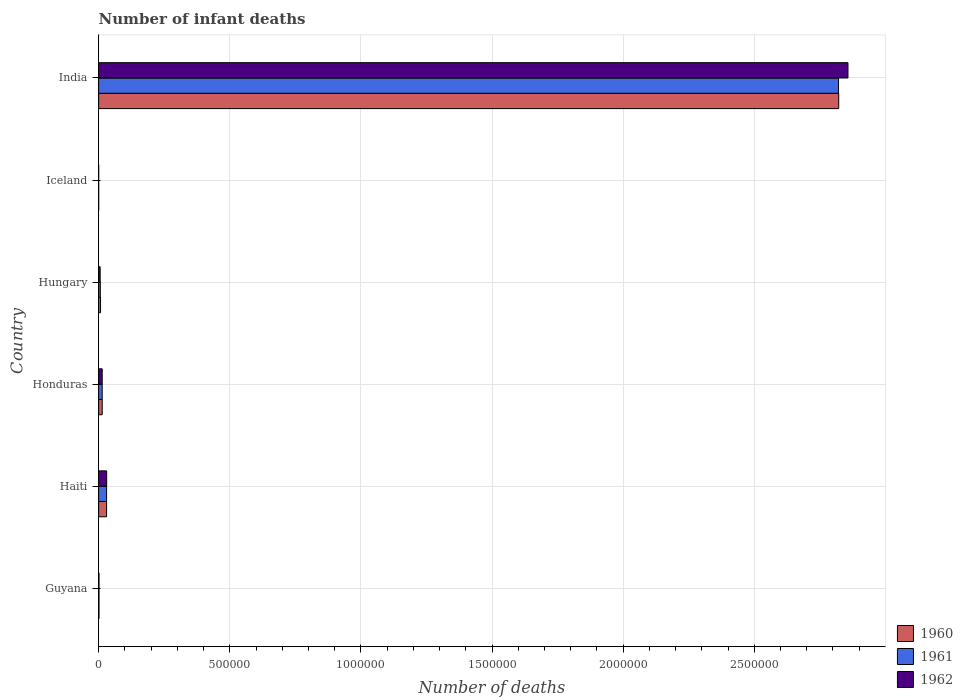How many different coloured bars are there?
Your answer should be very brief. 3. Are the number of bars on each tick of the Y-axis equal?
Offer a very short reply. Yes. What is the label of the 4th group of bars from the top?
Keep it short and to the point. Honduras. What is the number of infant deaths in 1962 in Hungary?
Ensure brevity in your answer.  5804. Across all countries, what is the maximum number of infant deaths in 1961?
Provide a short and direct response. 2.82e+06. Across all countries, what is the minimum number of infant deaths in 1961?
Give a very brief answer. 85. In which country was the number of infant deaths in 1960 maximum?
Your answer should be compact. India. What is the total number of infant deaths in 1961 in the graph?
Keep it short and to the point. 2.87e+06. What is the difference between the number of infant deaths in 1962 in Iceland and that in India?
Give a very brief answer. -2.86e+06. What is the difference between the number of infant deaths in 1961 in India and the number of infant deaths in 1962 in Hungary?
Make the answer very short. 2.82e+06. What is the average number of infant deaths in 1960 per country?
Your answer should be compact. 4.79e+05. What is the ratio of the number of infant deaths in 1960 in Guyana to that in Iceland?
Your answer should be compact. 15.6. Is the number of infant deaths in 1962 in Guyana less than that in Haiti?
Your answer should be very brief. Yes. Is the difference between the number of infant deaths in 1960 in Honduras and India greater than the difference between the number of infant deaths in 1961 in Honduras and India?
Your response must be concise. No. What is the difference between the highest and the second highest number of infant deaths in 1962?
Offer a very short reply. 2.83e+06. What is the difference between the highest and the lowest number of infant deaths in 1961?
Offer a very short reply. 2.82e+06. Is the sum of the number of infant deaths in 1960 in Haiti and Honduras greater than the maximum number of infant deaths in 1961 across all countries?
Make the answer very short. No. What does the 1st bar from the top in Hungary represents?
Provide a short and direct response. 1962. What does the 3rd bar from the bottom in Iceland represents?
Provide a succinct answer. 1962. Is it the case that in every country, the sum of the number of infant deaths in 1962 and number of infant deaths in 1960 is greater than the number of infant deaths in 1961?
Offer a very short reply. Yes. How many bars are there?
Make the answer very short. 18. How many countries are there in the graph?
Give a very brief answer. 6. Are the values on the major ticks of X-axis written in scientific E-notation?
Provide a succinct answer. No. Does the graph contain grids?
Your answer should be very brief. Yes. How many legend labels are there?
Make the answer very short. 3. How are the legend labels stacked?
Offer a very short reply. Vertical. What is the title of the graph?
Make the answer very short. Number of infant deaths. Does "1960" appear as one of the legend labels in the graph?
Give a very brief answer. Yes. What is the label or title of the X-axis?
Keep it short and to the point. Number of deaths. What is the Number of deaths of 1960 in Guyana?
Provide a short and direct response. 1357. What is the Number of deaths of 1961 in Guyana?
Ensure brevity in your answer.  1386. What is the Number of deaths of 1962 in Guyana?
Give a very brief answer. 1434. What is the Number of deaths of 1960 in Haiti?
Ensure brevity in your answer.  3.03e+04. What is the Number of deaths of 1961 in Haiti?
Your answer should be compact. 3.03e+04. What is the Number of deaths in 1962 in Haiti?
Ensure brevity in your answer.  3.07e+04. What is the Number of deaths of 1960 in Honduras?
Your response must be concise. 1.37e+04. What is the Number of deaths in 1961 in Honduras?
Offer a terse response. 1.36e+04. What is the Number of deaths of 1962 in Honduras?
Provide a short and direct response. 1.36e+04. What is the Number of deaths in 1960 in Hungary?
Provide a short and direct response. 7310. What is the Number of deaths in 1961 in Hungary?
Offer a very short reply. 6403. What is the Number of deaths in 1962 in Hungary?
Provide a succinct answer. 5804. What is the Number of deaths in 1960 in India?
Your response must be concise. 2.82e+06. What is the Number of deaths of 1961 in India?
Provide a short and direct response. 2.82e+06. What is the Number of deaths of 1962 in India?
Keep it short and to the point. 2.86e+06. Across all countries, what is the maximum Number of deaths of 1960?
Make the answer very short. 2.82e+06. Across all countries, what is the maximum Number of deaths in 1961?
Keep it short and to the point. 2.82e+06. Across all countries, what is the maximum Number of deaths in 1962?
Offer a very short reply. 2.86e+06. What is the total Number of deaths of 1960 in the graph?
Give a very brief answer. 2.87e+06. What is the total Number of deaths in 1961 in the graph?
Offer a terse response. 2.87e+06. What is the total Number of deaths in 1962 in the graph?
Your answer should be compact. 2.91e+06. What is the difference between the Number of deaths of 1960 in Guyana and that in Haiti?
Provide a succinct answer. -2.89e+04. What is the difference between the Number of deaths of 1961 in Guyana and that in Haiti?
Provide a succinct answer. -2.89e+04. What is the difference between the Number of deaths in 1962 in Guyana and that in Haiti?
Your answer should be compact. -2.92e+04. What is the difference between the Number of deaths in 1960 in Guyana and that in Honduras?
Provide a succinct answer. -1.23e+04. What is the difference between the Number of deaths in 1961 in Guyana and that in Honduras?
Provide a short and direct response. -1.22e+04. What is the difference between the Number of deaths of 1962 in Guyana and that in Honduras?
Provide a short and direct response. -1.21e+04. What is the difference between the Number of deaths of 1960 in Guyana and that in Hungary?
Your response must be concise. -5953. What is the difference between the Number of deaths of 1961 in Guyana and that in Hungary?
Your response must be concise. -5017. What is the difference between the Number of deaths in 1962 in Guyana and that in Hungary?
Provide a short and direct response. -4370. What is the difference between the Number of deaths in 1960 in Guyana and that in Iceland?
Your response must be concise. 1270. What is the difference between the Number of deaths in 1961 in Guyana and that in Iceland?
Offer a very short reply. 1301. What is the difference between the Number of deaths in 1962 in Guyana and that in Iceland?
Ensure brevity in your answer.  1351. What is the difference between the Number of deaths in 1960 in Guyana and that in India?
Give a very brief answer. -2.82e+06. What is the difference between the Number of deaths in 1961 in Guyana and that in India?
Ensure brevity in your answer.  -2.82e+06. What is the difference between the Number of deaths in 1962 in Guyana and that in India?
Give a very brief answer. -2.86e+06. What is the difference between the Number of deaths in 1960 in Haiti and that in Honduras?
Offer a very short reply. 1.66e+04. What is the difference between the Number of deaths in 1961 in Haiti and that in Honduras?
Your response must be concise. 1.67e+04. What is the difference between the Number of deaths of 1962 in Haiti and that in Honduras?
Provide a short and direct response. 1.71e+04. What is the difference between the Number of deaths of 1960 in Haiti and that in Hungary?
Make the answer very short. 2.30e+04. What is the difference between the Number of deaths of 1961 in Haiti and that in Hungary?
Offer a very short reply. 2.39e+04. What is the difference between the Number of deaths in 1962 in Haiti and that in Hungary?
Your answer should be compact. 2.48e+04. What is the difference between the Number of deaths of 1960 in Haiti and that in Iceland?
Offer a terse response. 3.02e+04. What is the difference between the Number of deaths in 1961 in Haiti and that in Iceland?
Keep it short and to the point. 3.02e+04. What is the difference between the Number of deaths of 1962 in Haiti and that in Iceland?
Offer a terse response. 3.06e+04. What is the difference between the Number of deaths in 1960 in Haiti and that in India?
Ensure brevity in your answer.  -2.79e+06. What is the difference between the Number of deaths of 1961 in Haiti and that in India?
Provide a short and direct response. -2.79e+06. What is the difference between the Number of deaths of 1962 in Haiti and that in India?
Offer a very short reply. -2.83e+06. What is the difference between the Number of deaths of 1960 in Honduras and that in Hungary?
Your answer should be very brief. 6364. What is the difference between the Number of deaths in 1961 in Honduras and that in Hungary?
Your answer should be very brief. 7183. What is the difference between the Number of deaths in 1962 in Honduras and that in Hungary?
Your answer should be very brief. 7777. What is the difference between the Number of deaths of 1960 in Honduras and that in Iceland?
Your answer should be compact. 1.36e+04. What is the difference between the Number of deaths of 1961 in Honduras and that in Iceland?
Offer a terse response. 1.35e+04. What is the difference between the Number of deaths in 1962 in Honduras and that in Iceland?
Provide a succinct answer. 1.35e+04. What is the difference between the Number of deaths of 1960 in Honduras and that in India?
Offer a very short reply. -2.81e+06. What is the difference between the Number of deaths of 1961 in Honduras and that in India?
Offer a very short reply. -2.81e+06. What is the difference between the Number of deaths of 1962 in Honduras and that in India?
Keep it short and to the point. -2.84e+06. What is the difference between the Number of deaths of 1960 in Hungary and that in Iceland?
Offer a terse response. 7223. What is the difference between the Number of deaths of 1961 in Hungary and that in Iceland?
Keep it short and to the point. 6318. What is the difference between the Number of deaths in 1962 in Hungary and that in Iceland?
Provide a short and direct response. 5721. What is the difference between the Number of deaths of 1960 in Hungary and that in India?
Offer a very short reply. -2.81e+06. What is the difference between the Number of deaths in 1961 in Hungary and that in India?
Keep it short and to the point. -2.81e+06. What is the difference between the Number of deaths of 1962 in Hungary and that in India?
Provide a succinct answer. -2.85e+06. What is the difference between the Number of deaths in 1960 in Iceland and that in India?
Make the answer very short. -2.82e+06. What is the difference between the Number of deaths in 1961 in Iceland and that in India?
Offer a terse response. -2.82e+06. What is the difference between the Number of deaths of 1962 in Iceland and that in India?
Offer a very short reply. -2.86e+06. What is the difference between the Number of deaths in 1960 in Guyana and the Number of deaths in 1961 in Haiti?
Provide a succinct answer. -2.89e+04. What is the difference between the Number of deaths in 1960 in Guyana and the Number of deaths in 1962 in Haiti?
Ensure brevity in your answer.  -2.93e+04. What is the difference between the Number of deaths in 1961 in Guyana and the Number of deaths in 1962 in Haiti?
Your response must be concise. -2.93e+04. What is the difference between the Number of deaths in 1960 in Guyana and the Number of deaths in 1961 in Honduras?
Offer a terse response. -1.22e+04. What is the difference between the Number of deaths of 1960 in Guyana and the Number of deaths of 1962 in Honduras?
Your response must be concise. -1.22e+04. What is the difference between the Number of deaths of 1961 in Guyana and the Number of deaths of 1962 in Honduras?
Make the answer very short. -1.22e+04. What is the difference between the Number of deaths of 1960 in Guyana and the Number of deaths of 1961 in Hungary?
Your answer should be compact. -5046. What is the difference between the Number of deaths in 1960 in Guyana and the Number of deaths in 1962 in Hungary?
Your answer should be very brief. -4447. What is the difference between the Number of deaths in 1961 in Guyana and the Number of deaths in 1962 in Hungary?
Ensure brevity in your answer.  -4418. What is the difference between the Number of deaths of 1960 in Guyana and the Number of deaths of 1961 in Iceland?
Make the answer very short. 1272. What is the difference between the Number of deaths of 1960 in Guyana and the Number of deaths of 1962 in Iceland?
Offer a terse response. 1274. What is the difference between the Number of deaths of 1961 in Guyana and the Number of deaths of 1962 in Iceland?
Keep it short and to the point. 1303. What is the difference between the Number of deaths of 1960 in Guyana and the Number of deaths of 1961 in India?
Ensure brevity in your answer.  -2.82e+06. What is the difference between the Number of deaths of 1960 in Guyana and the Number of deaths of 1962 in India?
Offer a very short reply. -2.86e+06. What is the difference between the Number of deaths of 1961 in Guyana and the Number of deaths of 1962 in India?
Offer a terse response. -2.86e+06. What is the difference between the Number of deaths in 1960 in Haiti and the Number of deaths in 1961 in Honduras?
Keep it short and to the point. 1.67e+04. What is the difference between the Number of deaths in 1960 in Haiti and the Number of deaths in 1962 in Honduras?
Ensure brevity in your answer.  1.67e+04. What is the difference between the Number of deaths of 1961 in Haiti and the Number of deaths of 1962 in Honduras?
Offer a very short reply. 1.67e+04. What is the difference between the Number of deaths of 1960 in Haiti and the Number of deaths of 1961 in Hungary?
Your answer should be compact. 2.39e+04. What is the difference between the Number of deaths of 1960 in Haiti and the Number of deaths of 1962 in Hungary?
Your response must be concise. 2.45e+04. What is the difference between the Number of deaths in 1961 in Haiti and the Number of deaths in 1962 in Hungary?
Make the answer very short. 2.45e+04. What is the difference between the Number of deaths in 1960 in Haiti and the Number of deaths in 1961 in Iceland?
Ensure brevity in your answer.  3.02e+04. What is the difference between the Number of deaths in 1960 in Haiti and the Number of deaths in 1962 in Iceland?
Your answer should be very brief. 3.02e+04. What is the difference between the Number of deaths of 1961 in Haiti and the Number of deaths of 1962 in Iceland?
Provide a succinct answer. 3.02e+04. What is the difference between the Number of deaths in 1960 in Haiti and the Number of deaths in 1961 in India?
Offer a terse response. -2.79e+06. What is the difference between the Number of deaths in 1960 in Haiti and the Number of deaths in 1962 in India?
Offer a very short reply. -2.83e+06. What is the difference between the Number of deaths of 1961 in Haiti and the Number of deaths of 1962 in India?
Your answer should be compact. -2.83e+06. What is the difference between the Number of deaths in 1960 in Honduras and the Number of deaths in 1961 in Hungary?
Your response must be concise. 7271. What is the difference between the Number of deaths of 1960 in Honduras and the Number of deaths of 1962 in Hungary?
Offer a very short reply. 7870. What is the difference between the Number of deaths in 1961 in Honduras and the Number of deaths in 1962 in Hungary?
Provide a succinct answer. 7782. What is the difference between the Number of deaths of 1960 in Honduras and the Number of deaths of 1961 in Iceland?
Ensure brevity in your answer.  1.36e+04. What is the difference between the Number of deaths of 1960 in Honduras and the Number of deaths of 1962 in Iceland?
Offer a terse response. 1.36e+04. What is the difference between the Number of deaths in 1961 in Honduras and the Number of deaths in 1962 in Iceland?
Provide a succinct answer. 1.35e+04. What is the difference between the Number of deaths of 1960 in Honduras and the Number of deaths of 1961 in India?
Keep it short and to the point. -2.81e+06. What is the difference between the Number of deaths of 1960 in Honduras and the Number of deaths of 1962 in India?
Keep it short and to the point. -2.84e+06. What is the difference between the Number of deaths of 1961 in Honduras and the Number of deaths of 1962 in India?
Offer a terse response. -2.84e+06. What is the difference between the Number of deaths in 1960 in Hungary and the Number of deaths in 1961 in Iceland?
Provide a short and direct response. 7225. What is the difference between the Number of deaths in 1960 in Hungary and the Number of deaths in 1962 in Iceland?
Make the answer very short. 7227. What is the difference between the Number of deaths of 1961 in Hungary and the Number of deaths of 1962 in Iceland?
Your response must be concise. 6320. What is the difference between the Number of deaths in 1960 in Hungary and the Number of deaths in 1961 in India?
Your answer should be compact. -2.81e+06. What is the difference between the Number of deaths in 1960 in Hungary and the Number of deaths in 1962 in India?
Provide a short and direct response. -2.85e+06. What is the difference between the Number of deaths of 1961 in Hungary and the Number of deaths of 1962 in India?
Your response must be concise. -2.85e+06. What is the difference between the Number of deaths in 1960 in Iceland and the Number of deaths in 1961 in India?
Offer a very short reply. -2.82e+06. What is the difference between the Number of deaths in 1960 in Iceland and the Number of deaths in 1962 in India?
Offer a terse response. -2.86e+06. What is the difference between the Number of deaths of 1961 in Iceland and the Number of deaths of 1962 in India?
Your answer should be very brief. -2.86e+06. What is the average Number of deaths in 1960 per country?
Provide a short and direct response. 4.79e+05. What is the average Number of deaths of 1961 per country?
Your answer should be very brief. 4.79e+05. What is the average Number of deaths of 1962 per country?
Your answer should be compact. 4.85e+05. What is the difference between the Number of deaths in 1960 and Number of deaths in 1961 in Guyana?
Keep it short and to the point. -29. What is the difference between the Number of deaths in 1960 and Number of deaths in 1962 in Guyana?
Provide a succinct answer. -77. What is the difference between the Number of deaths in 1961 and Number of deaths in 1962 in Guyana?
Offer a terse response. -48. What is the difference between the Number of deaths of 1960 and Number of deaths of 1962 in Haiti?
Make the answer very short. -373. What is the difference between the Number of deaths of 1961 and Number of deaths of 1962 in Haiti?
Offer a very short reply. -352. What is the difference between the Number of deaths in 1960 and Number of deaths in 1961 in Honduras?
Your response must be concise. 88. What is the difference between the Number of deaths in 1960 and Number of deaths in 1962 in Honduras?
Give a very brief answer. 93. What is the difference between the Number of deaths of 1960 and Number of deaths of 1961 in Hungary?
Your response must be concise. 907. What is the difference between the Number of deaths in 1960 and Number of deaths in 1962 in Hungary?
Your answer should be compact. 1506. What is the difference between the Number of deaths of 1961 and Number of deaths of 1962 in Hungary?
Offer a terse response. 599. What is the difference between the Number of deaths of 1960 and Number of deaths of 1962 in Iceland?
Your answer should be very brief. 4. What is the difference between the Number of deaths of 1960 and Number of deaths of 1961 in India?
Offer a very short reply. 784. What is the difference between the Number of deaths in 1960 and Number of deaths in 1962 in India?
Keep it short and to the point. -3.53e+04. What is the difference between the Number of deaths of 1961 and Number of deaths of 1962 in India?
Ensure brevity in your answer.  -3.60e+04. What is the ratio of the Number of deaths of 1960 in Guyana to that in Haiti?
Ensure brevity in your answer.  0.04. What is the ratio of the Number of deaths of 1961 in Guyana to that in Haiti?
Your answer should be very brief. 0.05. What is the ratio of the Number of deaths of 1962 in Guyana to that in Haiti?
Your response must be concise. 0.05. What is the ratio of the Number of deaths of 1960 in Guyana to that in Honduras?
Keep it short and to the point. 0.1. What is the ratio of the Number of deaths of 1961 in Guyana to that in Honduras?
Your response must be concise. 0.1. What is the ratio of the Number of deaths in 1962 in Guyana to that in Honduras?
Your answer should be very brief. 0.11. What is the ratio of the Number of deaths in 1960 in Guyana to that in Hungary?
Offer a terse response. 0.19. What is the ratio of the Number of deaths in 1961 in Guyana to that in Hungary?
Offer a very short reply. 0.22. What is the ratio of the Number of deaths in 1962 in Guyana to that in Hungary?
Your answer should be very brief. 0.25. What is the ratio of the Number of deaths of 1960 in Guyana to that in Iceland?
Make the answer very short. 15.6. What is the ratio of the Number of deaths of 1961 in Guyana to that in Iceland?
Make the answer very short. 16.31. What is the ratio of the Number of deaths in 1962 in Guyana to that in Iceland?
Provide a succinct answer. 17.28. What is the ratio of the Number of deaths in 1960 in Guyana to that in India?
Make the answer very short. 0. What is the ratio of the Number of deaths of 1962 in Guyana to that in India?
Offer a very short reply. 0. What is the ratio of the Number of deaths of 1960 in Haiti to that in Honduras?
Your response must be concise. 2.21. What is the ratio of the Number of deaths of 1961 in Haiti to that in Honduras?
Provide a short and direct response. 2.23. What is the ratio of the Number of deaths of 1962 in Haiti to that in Honduras?
Your answer should be compact. 2.26. What is the ratio of the Number of deaths of 1960 in Haiti to that in Hungary?
Ensure brevity in your answer.  4.14. What is the ratio of the Number of deaths in 1961 in Haiti to that in Hungary?
Make the answer very short. 4.73. What is the ratio of the Number of deaths of 1962 in Haiti to that in Hungary?
Offer a terse response. 5.28. What is the ratio of the Number of deaths in 1960 in Haiti to that in Iceland?
Keep it short and to the point. 348.06. What is the ratio of the Number of deaths in 1961 in Haiti to that in Iceland?
Your response must be concise. 356.49. What is the ratio of the Number of deaths in 1962 in Haiti to that in Iceland?
Provide a short and direct response. 369.33. What is the ratio of the Number of deaths in 1960 in Haiti to that in India?
Provide a succinct answer. 0.01. What is the ratio of the Number of deaths of 1961 in Haiti to that in India?
Offer a very short reply. 0.01. What is the ratio of the Number of deaths in 1962 in Haiti to that in India?
Provide a short and direct response. 0.01. What is the ratio of the Number of deaths in 1960 in Honduras to that in Hungary?
Keep it short and to the point. 1.87. What is the ratio of the Number of deaths of 1961 in Honduras to that in Hungary?
Your response must be concise. 2.12. What is the ratio of the Number of deaths in 1962 in Honduras to that in Hungary?
Offer a very short reply. 2.34. What is the ratio of the Number of deaths in 1960 in Honduras to that in Iceland?
Your response must be concise. 157.17. What is the ratio of the Number of deaths of 1961 in Honduras to that in Iceland?
Offer a terse response. 159.84. What is the ratio of the Number of deaths in 1962 in Honduras to that in Iceland?
Ensure brevity in your answer.  163.63. What is the ratio of the Number of deaths in 1960 in Honduras to that in India?
Offer a very short reply. 0. What is the ratio of the Number of deaths of 1961 in Honduras to that in India?
Your answer should be compact. 0. What is the ratio of the Number of deaths of 1962 in Honduras to that in India?
Your answer should be very brief. 0. What is the ratio of the Number of deaths of 1960 in Hungary to that in Iceland?
Your answer should be compact. 84.02. What is the ratio of the Number of deaths of 1961 in Hungary to that in Iceland?
Offer a very short reply. 75.33. What is the ratio of the Number of deaths in 1962 in Hungary to that in Iceland?
Keep it short and to the point. 69.93. What is the ratio of the Number of deaths in 1960 in Hungary to that in India?
Give a very brief answer. 0. What is the ratio of the Number of deaths in 1961 in Hungary to that in India?
Keep it short and to the point. 0. What is the ratio of the Number of deaths of 1962 in Hungary to that in India?
Provide a succinct answer. 0. What is the ratio of the Number of deaths in 1960 in Iceland to that in India?
Your answer should be compact. 0. What is the ratio of the Number of deaths in 1962 in Iceland to that in India?
Your answer should be compact. 0. What is the difference between the highest and the second highest Number of deaths of 1960?
Give a very brief answer. 2.79e+06. What is the difference between the highest and the second highest Number of deaths of 1961?
Give a very brief answer. 2.79e+06. What is the difference between the highest and the second highest Number of deaths of 1962?
Give a very brief answer. 2.83e+06. What is the difference between the highest and the lowest Number of deaths of 1960?
Keep it short and to the point. 2.82e+06. What is the difference between the highest and the lowest Number of deaths of 1961?
Make the answer very short. 2.82e+06. What is the difference between the highest and the lowest Number of deaths of 1962?
Your response must be concise. 2.86e+06. 